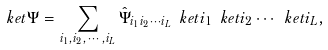Convert formula to latex. <formula><loc_0><loc_0><loc_500><loc_500>\ k e t { \Psi } = \sum _ { i _ { 1 } , i _ { 2 } , \cdots , i _ { L } } \hat { \Psi } _ { i _ { 1 } i _ { 2 } \cdots i _ { L } } \ k e t { i _ { 1 } } \ k e t { i _ { 2 } } \cdots \ k e t { i _ { L } } ,</formula> 